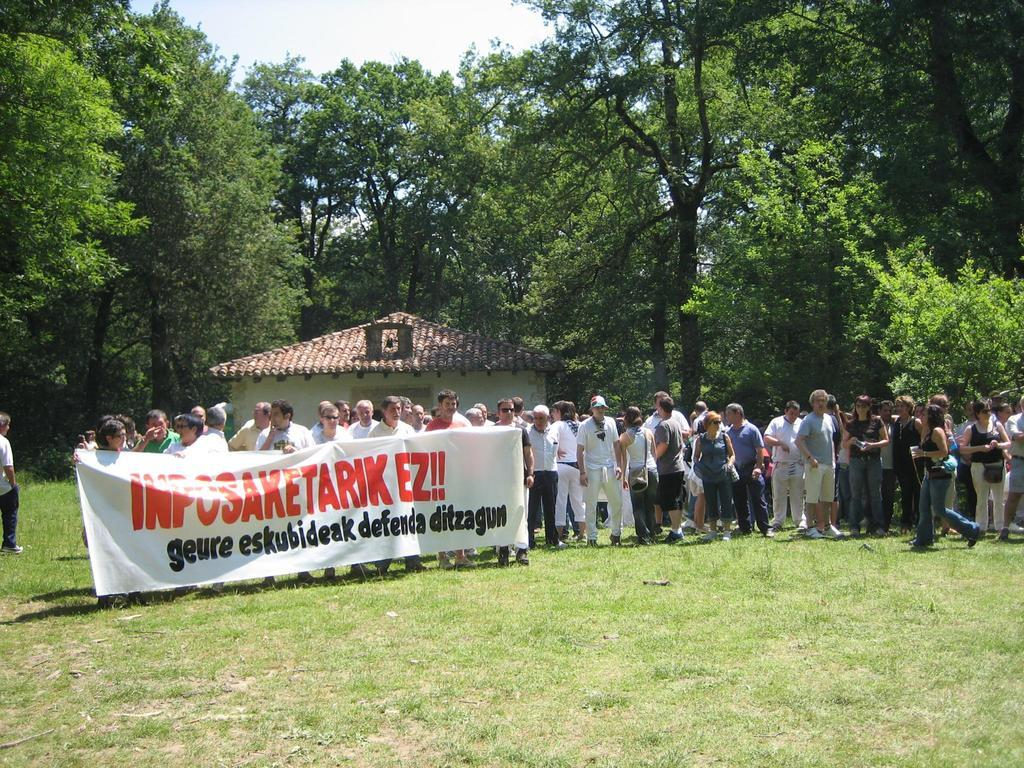How many people are in the image? There are people in the image, but the exact number is not specified. What are some people doing in the image? Some people are holding a banner in the image. What type of terrain is visible in the image? There is grass visible in the image. What can be seen in the background of the image? There is a house, trees, and the sky visible in the background of the image. How many friends does the person in the image have? The facts provided do not mention any specific person or their friends, so it is impossible to answer this question. 